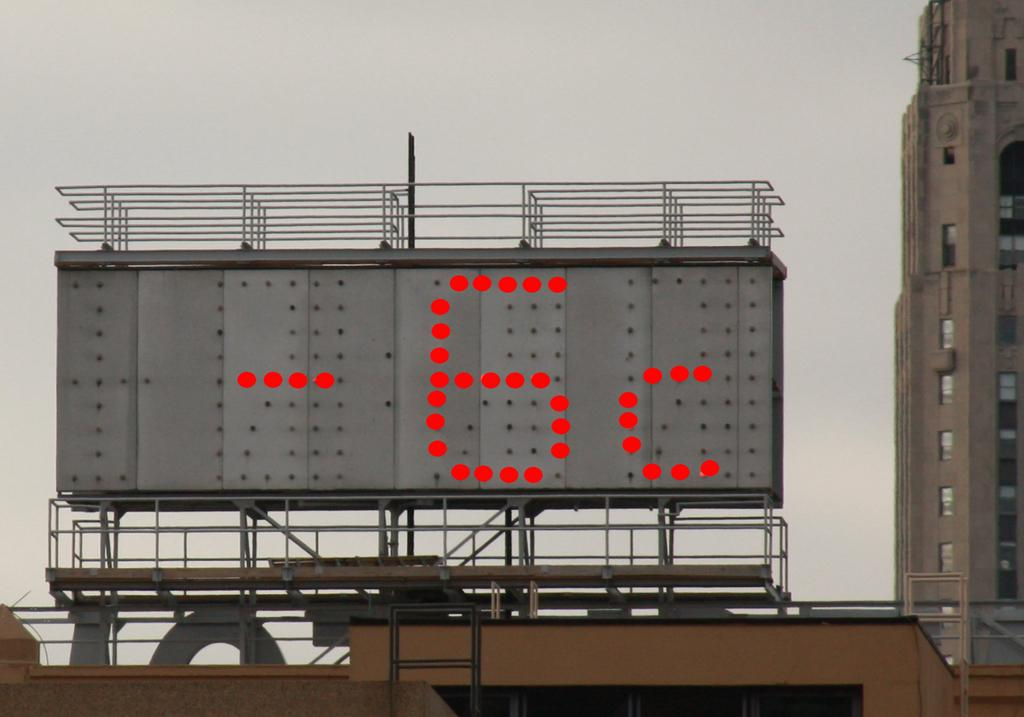<image>
Write a terse but informative summary of the picture. a sign that has the number -6 on it 